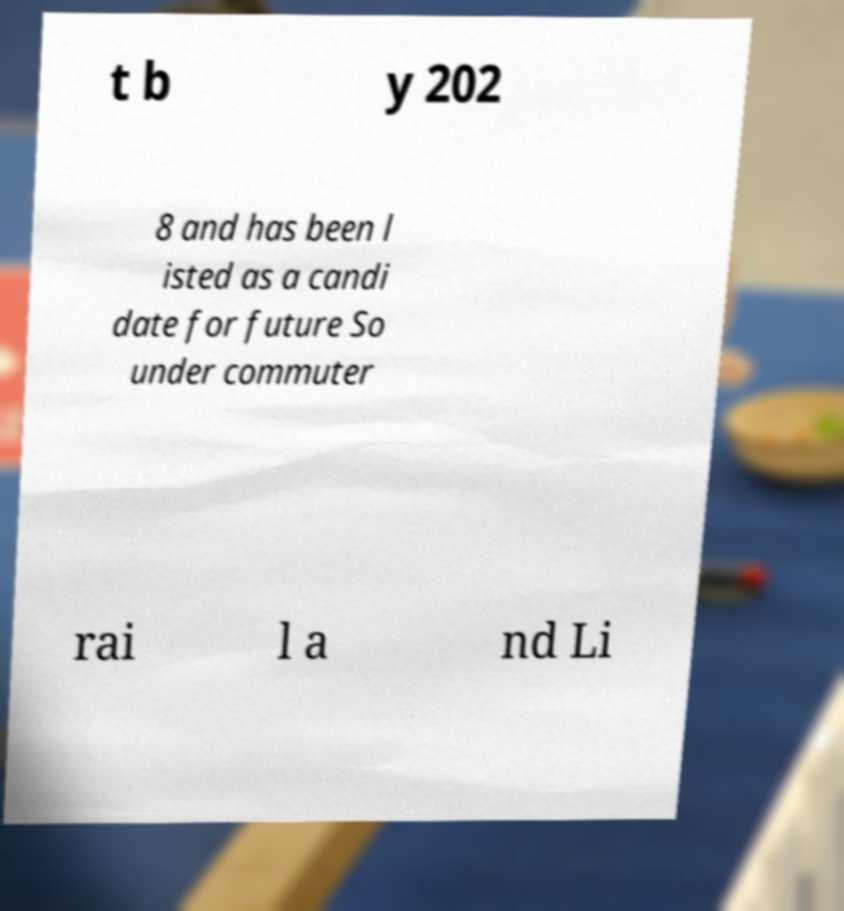Can you accurately transcribe the text from the provided image for me? t b y 202 8 and has been l isted as a candi date for future So under commuter rai l a nd Li 